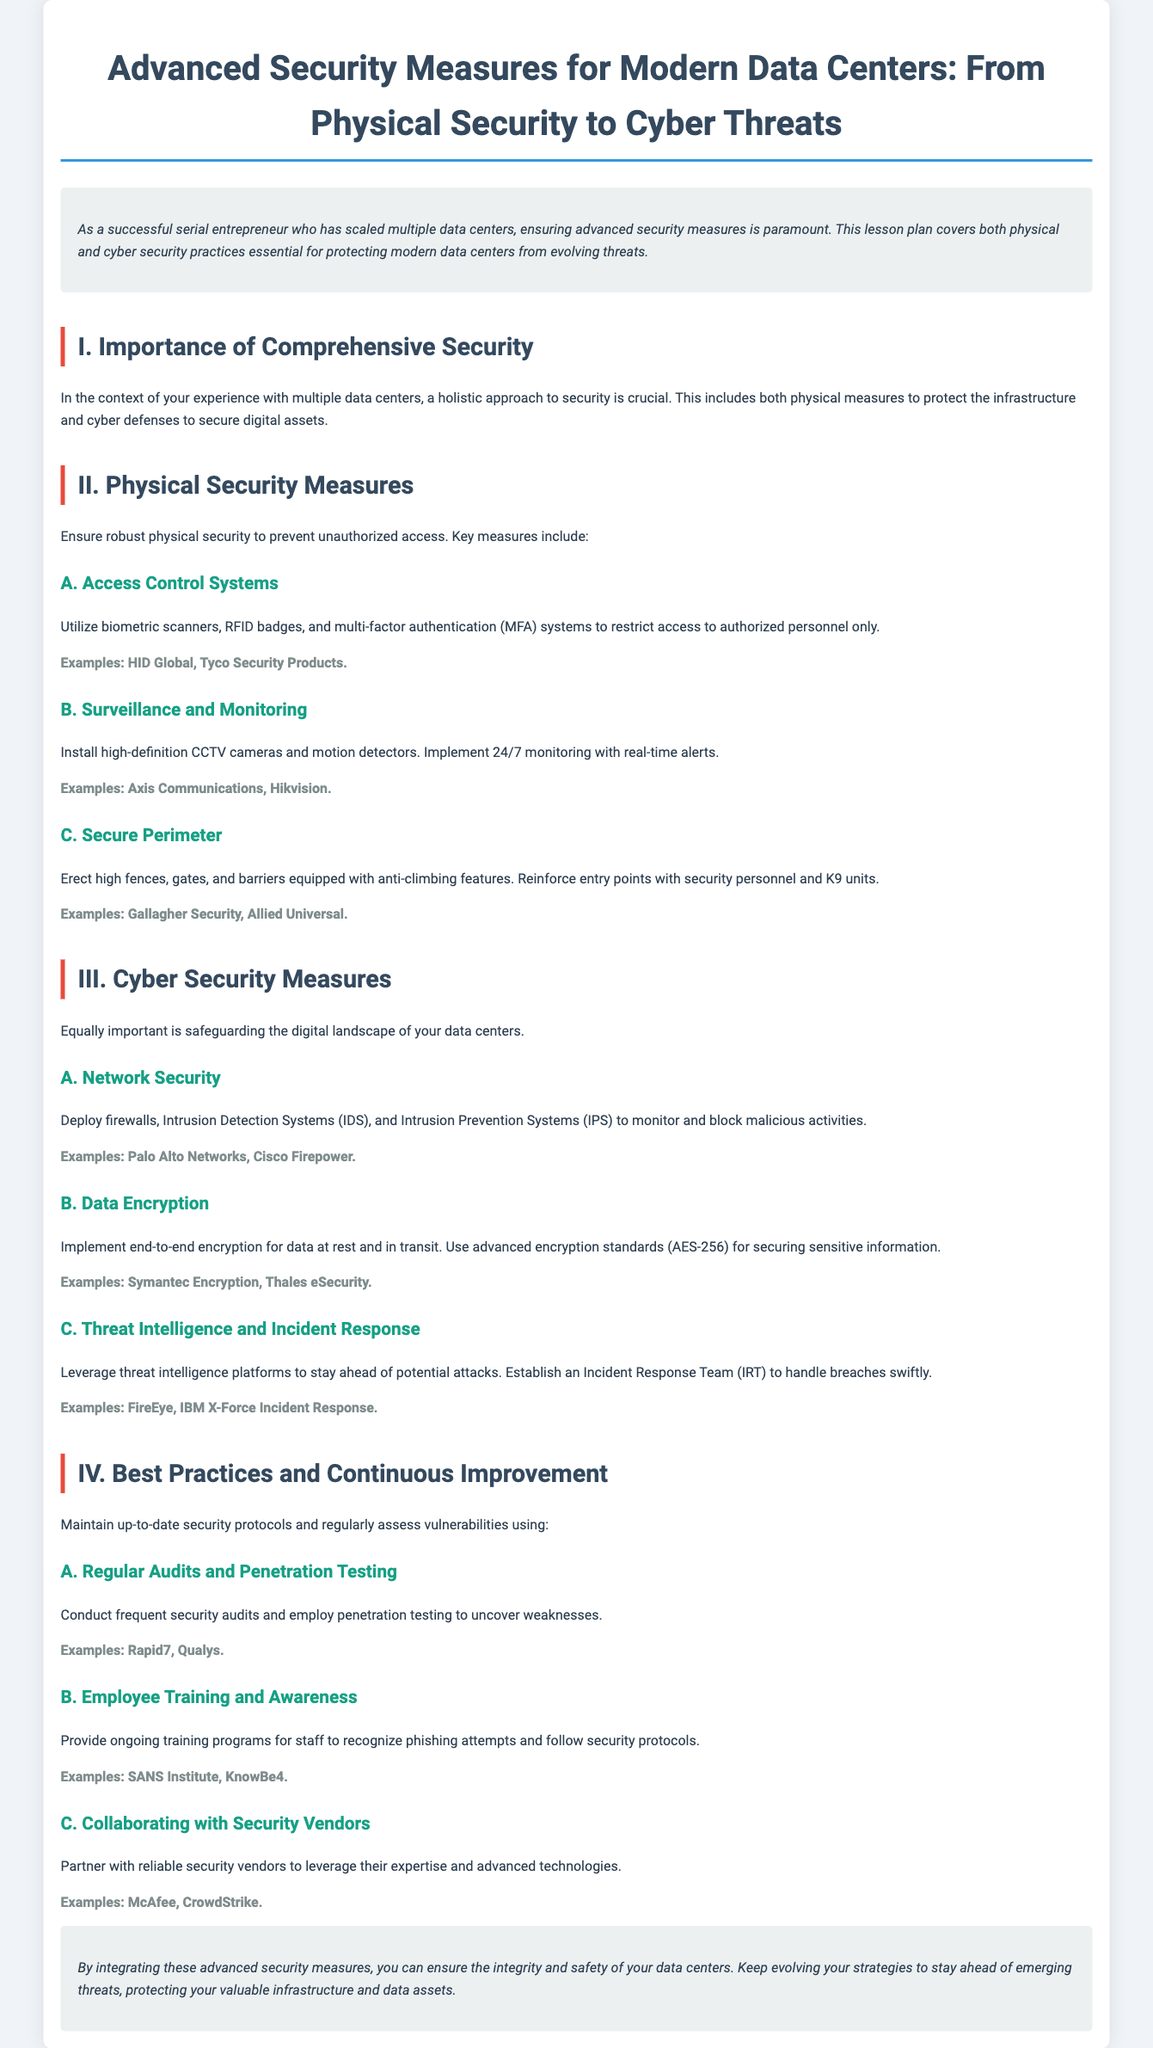What is the title of the lesson plan? The title of the lesson plan is stated in the document.
Answer: Advanced Security Measures for Modern Data Centers: From Physical Security to Cyber Threats What is the main focus of the lesson plan? The document outlines the focus of the lesson plan emphasizing security in data centers.
Answer: Advanced security measures What are two examples of access control systems mentioned? The document lists specific examples under the section for access control systems.
Answer: HID Global, Tyco Security Products What is one of the examples of data encryption solutions provided? The document includes examples under the data encryption section.
Answer: Symantec Encryption What is the recommended encryption standard for securing sensitive information? The document specifies the encryption standard used for data security.
Answer: AES-256 Which company is mentioned as an example for threat intelligence platforms? The document provides specific vendor examples in the cyber security measures section.
Answer: FireEye What is an important aspect of employee training according to the document? The document emphasizes ongoing training programs for specific purposes.
Answer: Recognizing phishing attempts What type of systems does the document suggest for network security? The lesson plan identifies specific systems to be deployed for network security.
Answer: Firewalls, IDS, IPS What does the conclusion emphasize about security strategies? The conclusion gives insights on the approach towards security strategies.
Answer: Evolving strategies to stay ahead of threats 